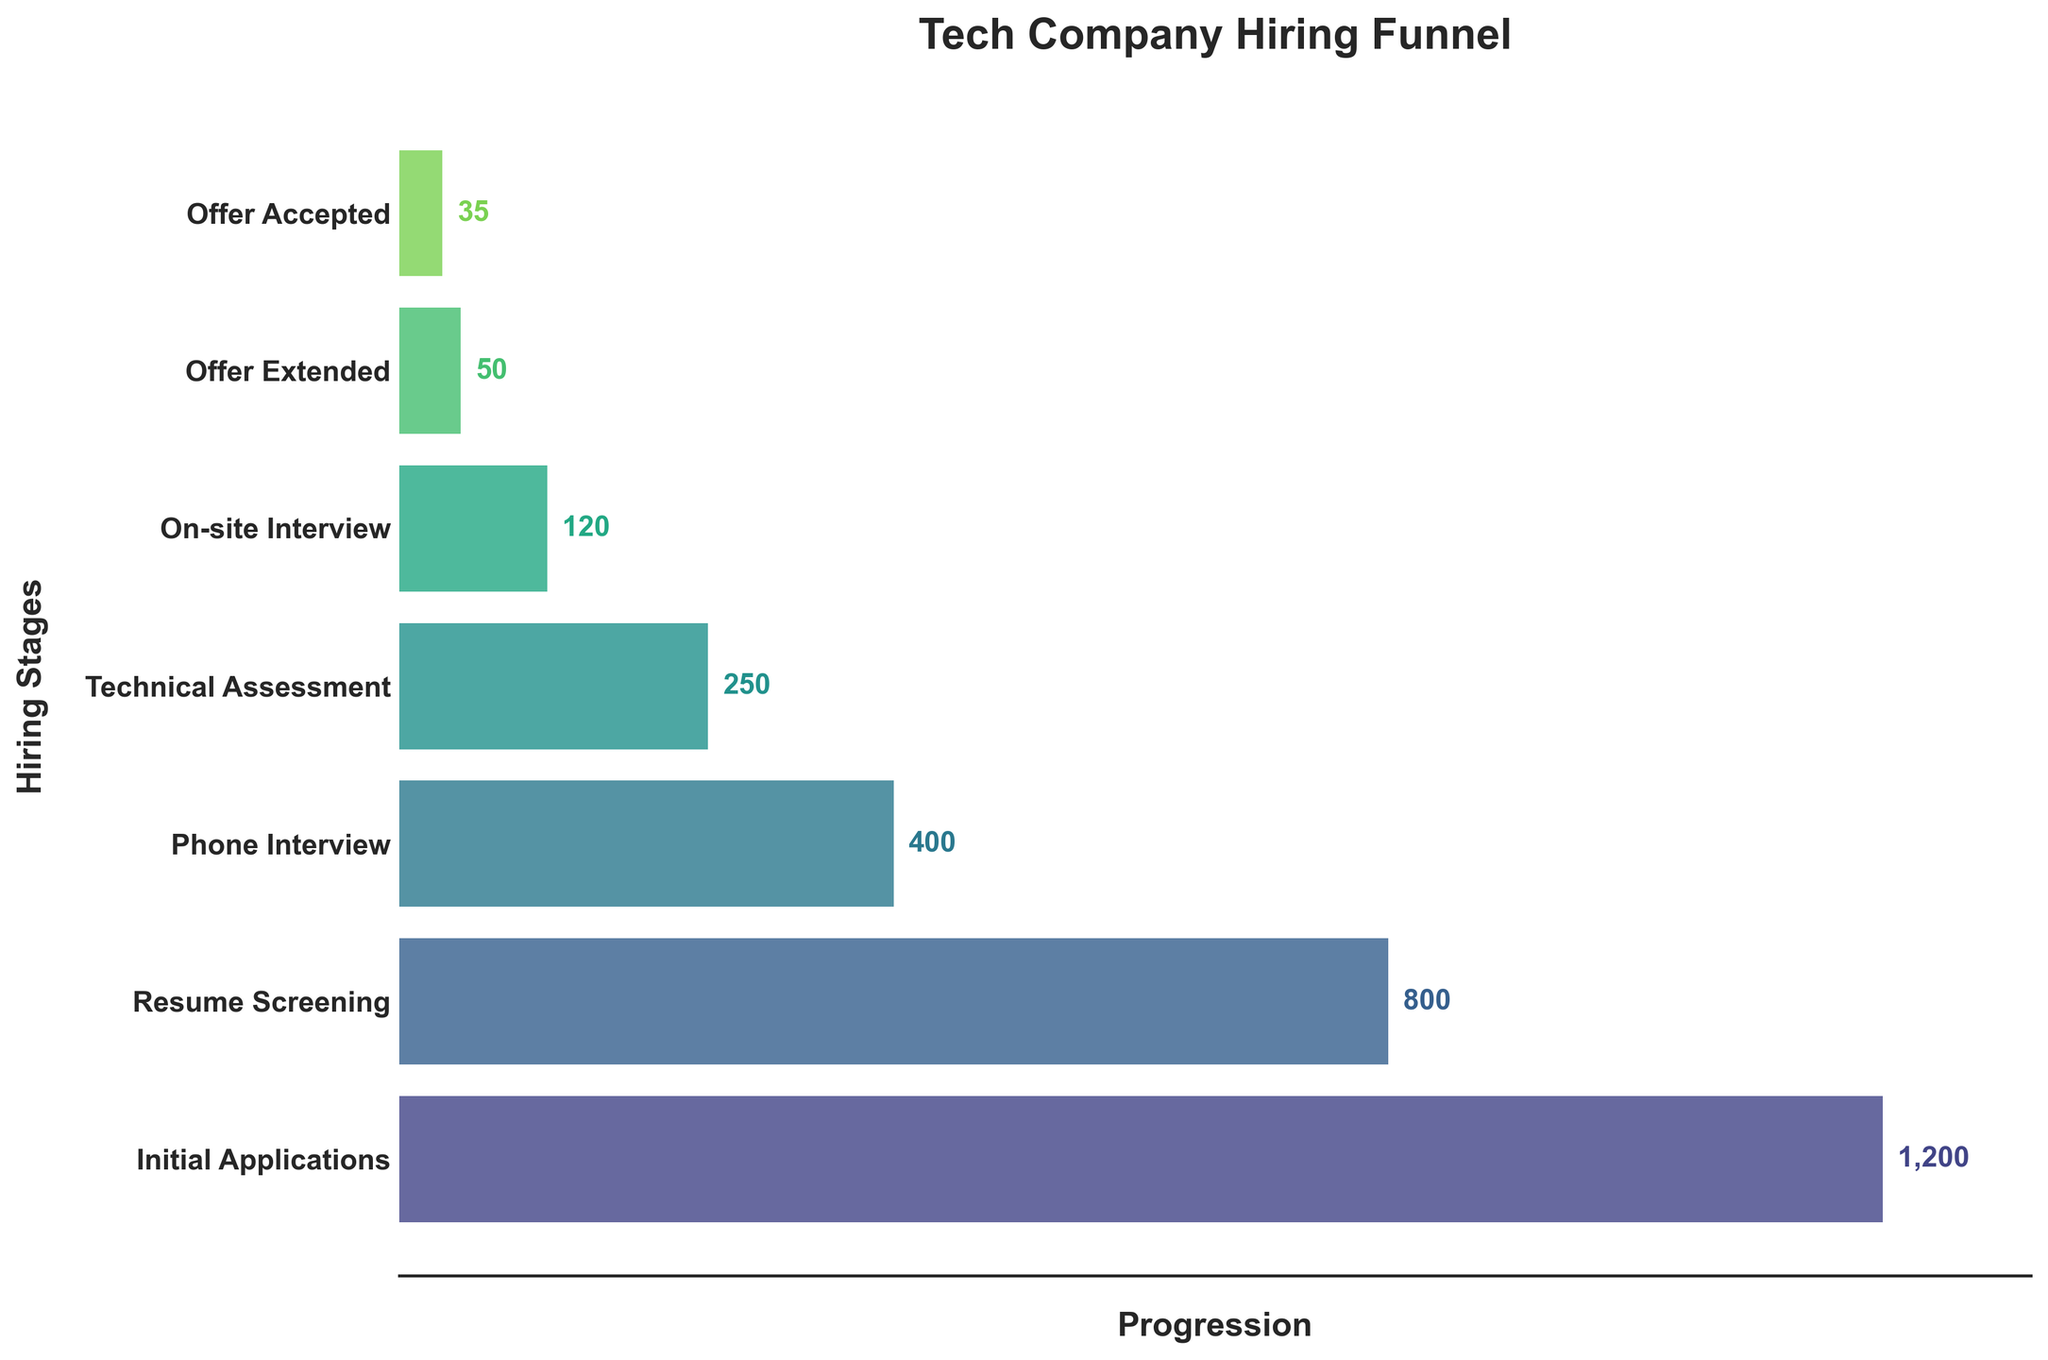What is the title of the chart? The title is usually placed at the top of the chart. In this case, it reads "Tech Company Hiring Funnel."
Answer: Tech Company Hiring Funnel Which hiring stage has the highest number of candidates? To find this, observe the chart and look for the stage with the longest bar. The longest bar represents "Initial Applications."
Answer: Initial Applications How many candidates made it to the 'On-site Interview' stage? Find the bar labeled 'On-site Interview' and refer to the number placed next to it on the chart. It shows '120'.
Answer: 120 What is the difference in the number of candidates between the 'Phone Interview' and 'Technical Assessment' stages? Subtract the number of candidates in 'Technical Assessment' (250) from those in 'Phone Interview' (400): 400 - 250 = 150.
Answer: 150 How many candidates were screened out after the 'Resume Screening' stage? Subtract the number of candidates who moved on to 'Phone Interview' (400) from those who were in 'Resume Screening' (800): 800 - 400 = 400.
Answer: 400 What percentage of initial applicants received an offer? Divide the number of offers extended (50) by the number of initial applications (1200) and multiply by 100 to get the percentage: (50 / 1200) * 100 ≈ 4.17%.
Answer: ~4.17% What stage sees the biggest drop in candidate numbers? The biggest drop is observed by comparing the length of each bar to the previous one. The largest decrease is from 'Phone Interview' (400) to 'Technical Assessment' (250), a drop of 150 candidates.
Answer: Phone Interview to Technical Assessment How many more candidates accepted the offer than declined it? Subtract the number of offer acceptances (35) from the number of extended offers (50): 50 - 35 = 15.
Answer: 15 